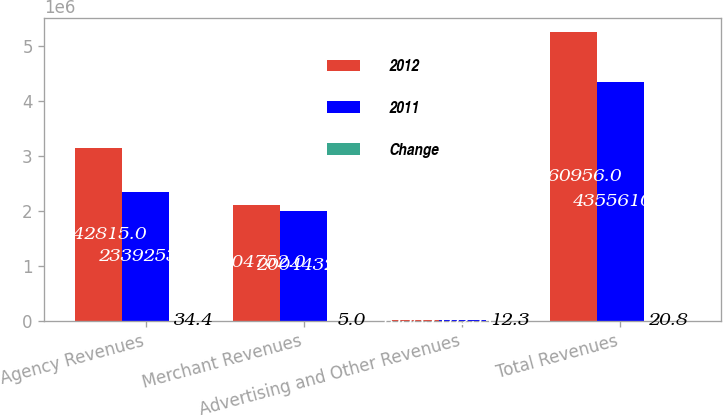Convert chart. <chart><loc_0><loc_0><loc_500><loc_500><stacked_bar_chart><ecel><fcel>Agency Revenues<fcel>Merchant Revenues<fcel>Advertising and Other Revenues<fcel>Total Revenues<nl><fcel>2012<fcel>3.14282e+06<fcel>2.10475e+06<fcel>13389<fcel>5.26096e+06<nl><fcel>2011<fcel>2.33925e+06<fcel>2.00443e+06<fcel>11925<fcel>4.35561e+06<nl><fcel>Change<fcel>34.4<fcel>5<fcel>12.3<fcel>20.8<nl></chart> 